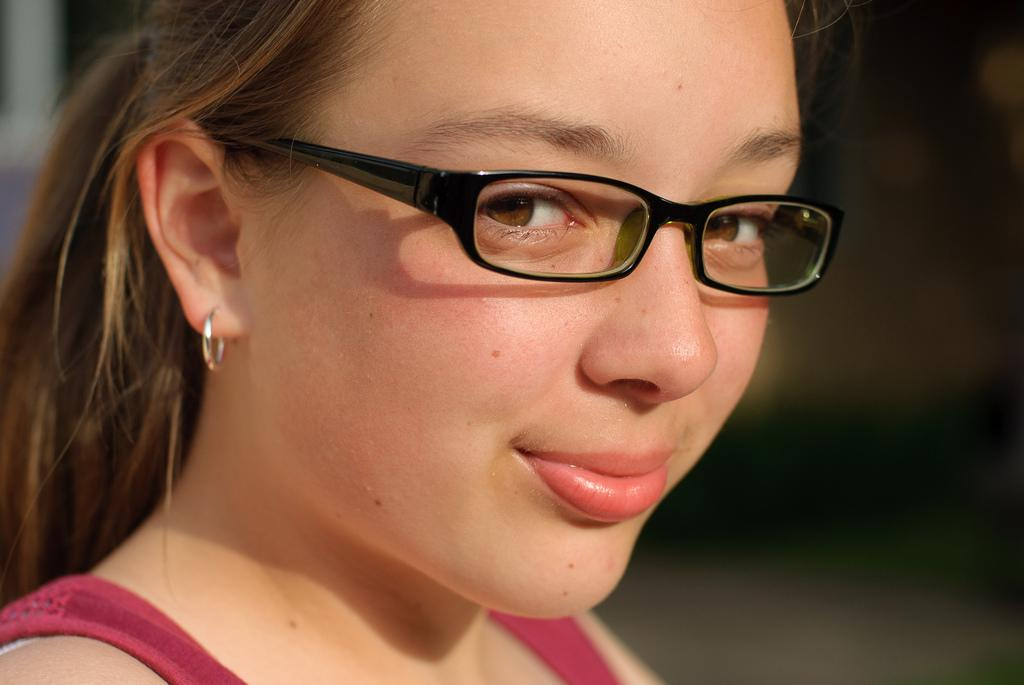Who is the main subject in the image? There is a girl in the image. Where is the girl positioned in the image? The girl is at the center of the image. What accessory is the girl wearing? The girl is wearing spectacles. What type of chair is the girl sitting on in the image? There is no chair present in the image; the girl is standing. What control does the girl have over the spectacles in the image? The image does not show the girl having any control over the spectacles, as they are already on her face. 